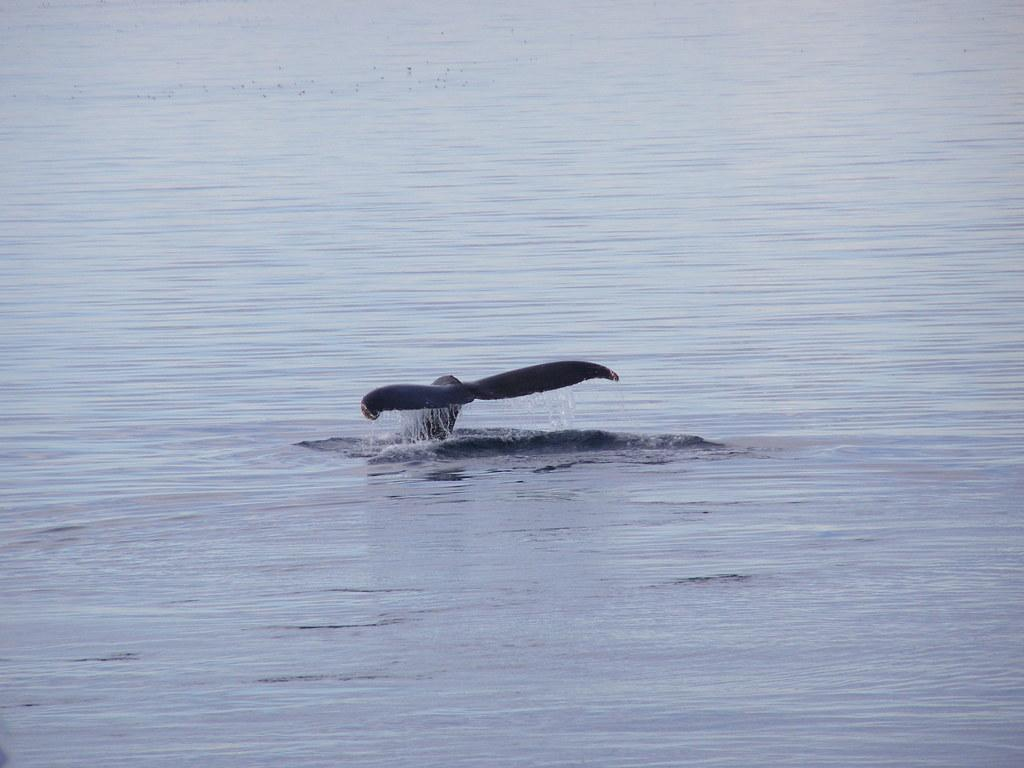What type of animal can be seen in the image? There is an aquatic animal in the image. How would you describe the color of the water in the image? The water in the image is in blue and white color. How many cherries are on the sand in the image? There are no cherries or sand present in the image; it features an aquatic animal in blue and white water. 